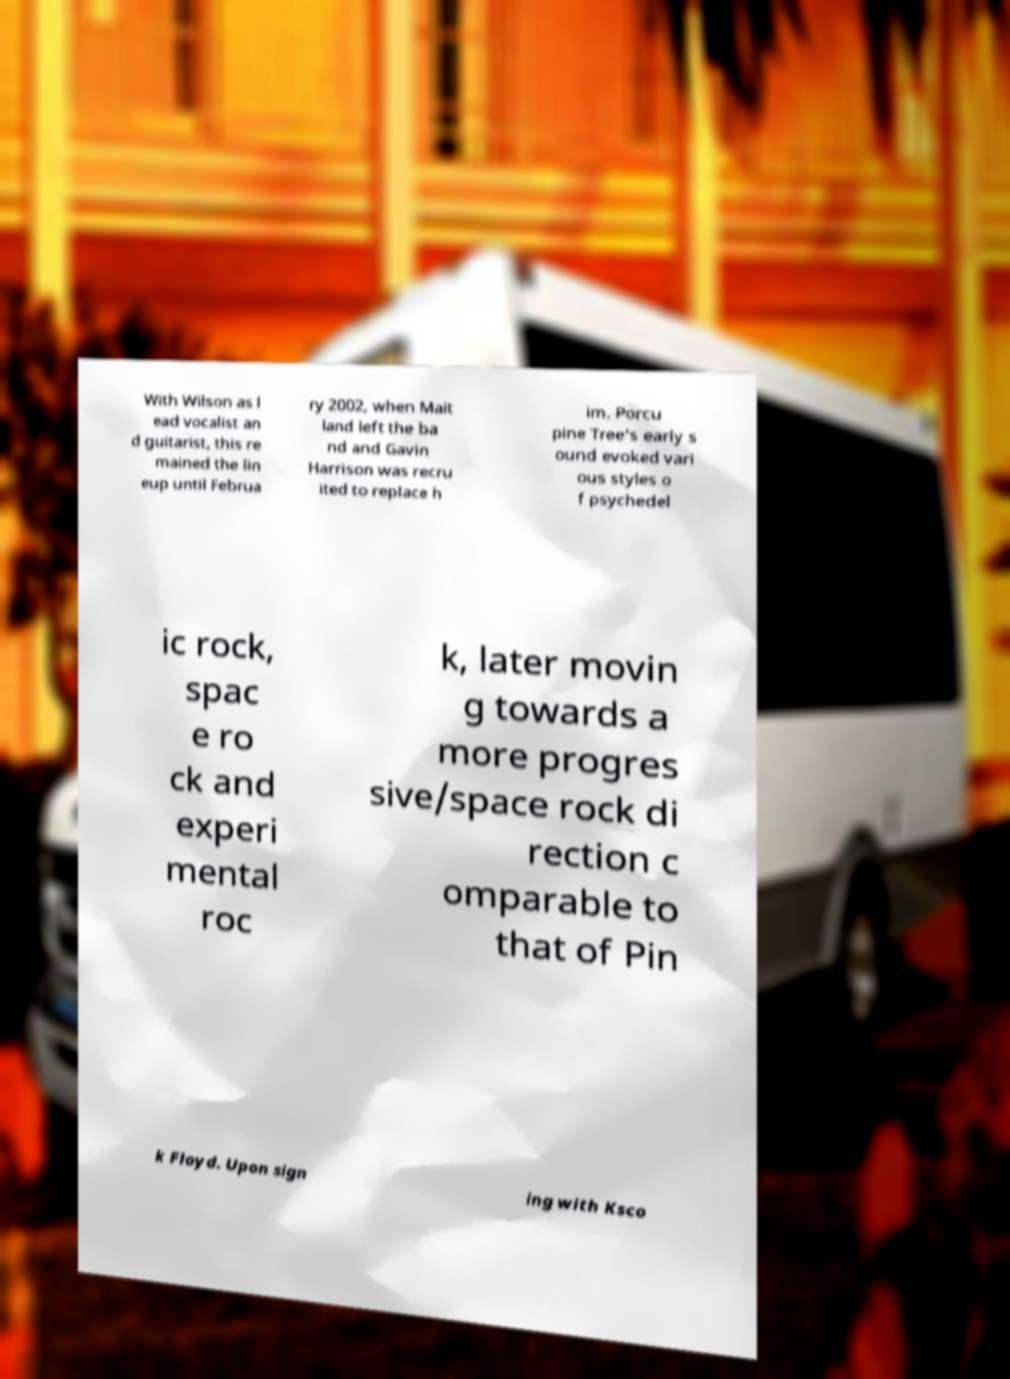Could you assist in decoding the text presented in this image and type it out clearly? With Wilson as l ead vocalist an d guitarist, this re mained the lin eup until Februa ry 2002, when Mait land left the ba nd and Gavin Harrison was recru ited to replace h im. Porcu pine Tree's early s ound evoked vari ous styles o f psychedel ic rock, spac e ro ck and experi mental roc k, later movin g towards a more progres sive/space rock di rection c omparable to that of Pin k Floyd. Upon sign ing with Ksco 